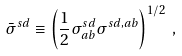<formula> <loc_0><loc_0><loc_500><loc_500>\bar { \sigma } ^ { s d } \equiv \left ( \frac { 1 } { 2 } \sigma ^ { s d } _ { a b } \sigma ^ { s d , a b } \right ) ^ { 1 / 2 } \, ,</formula> 